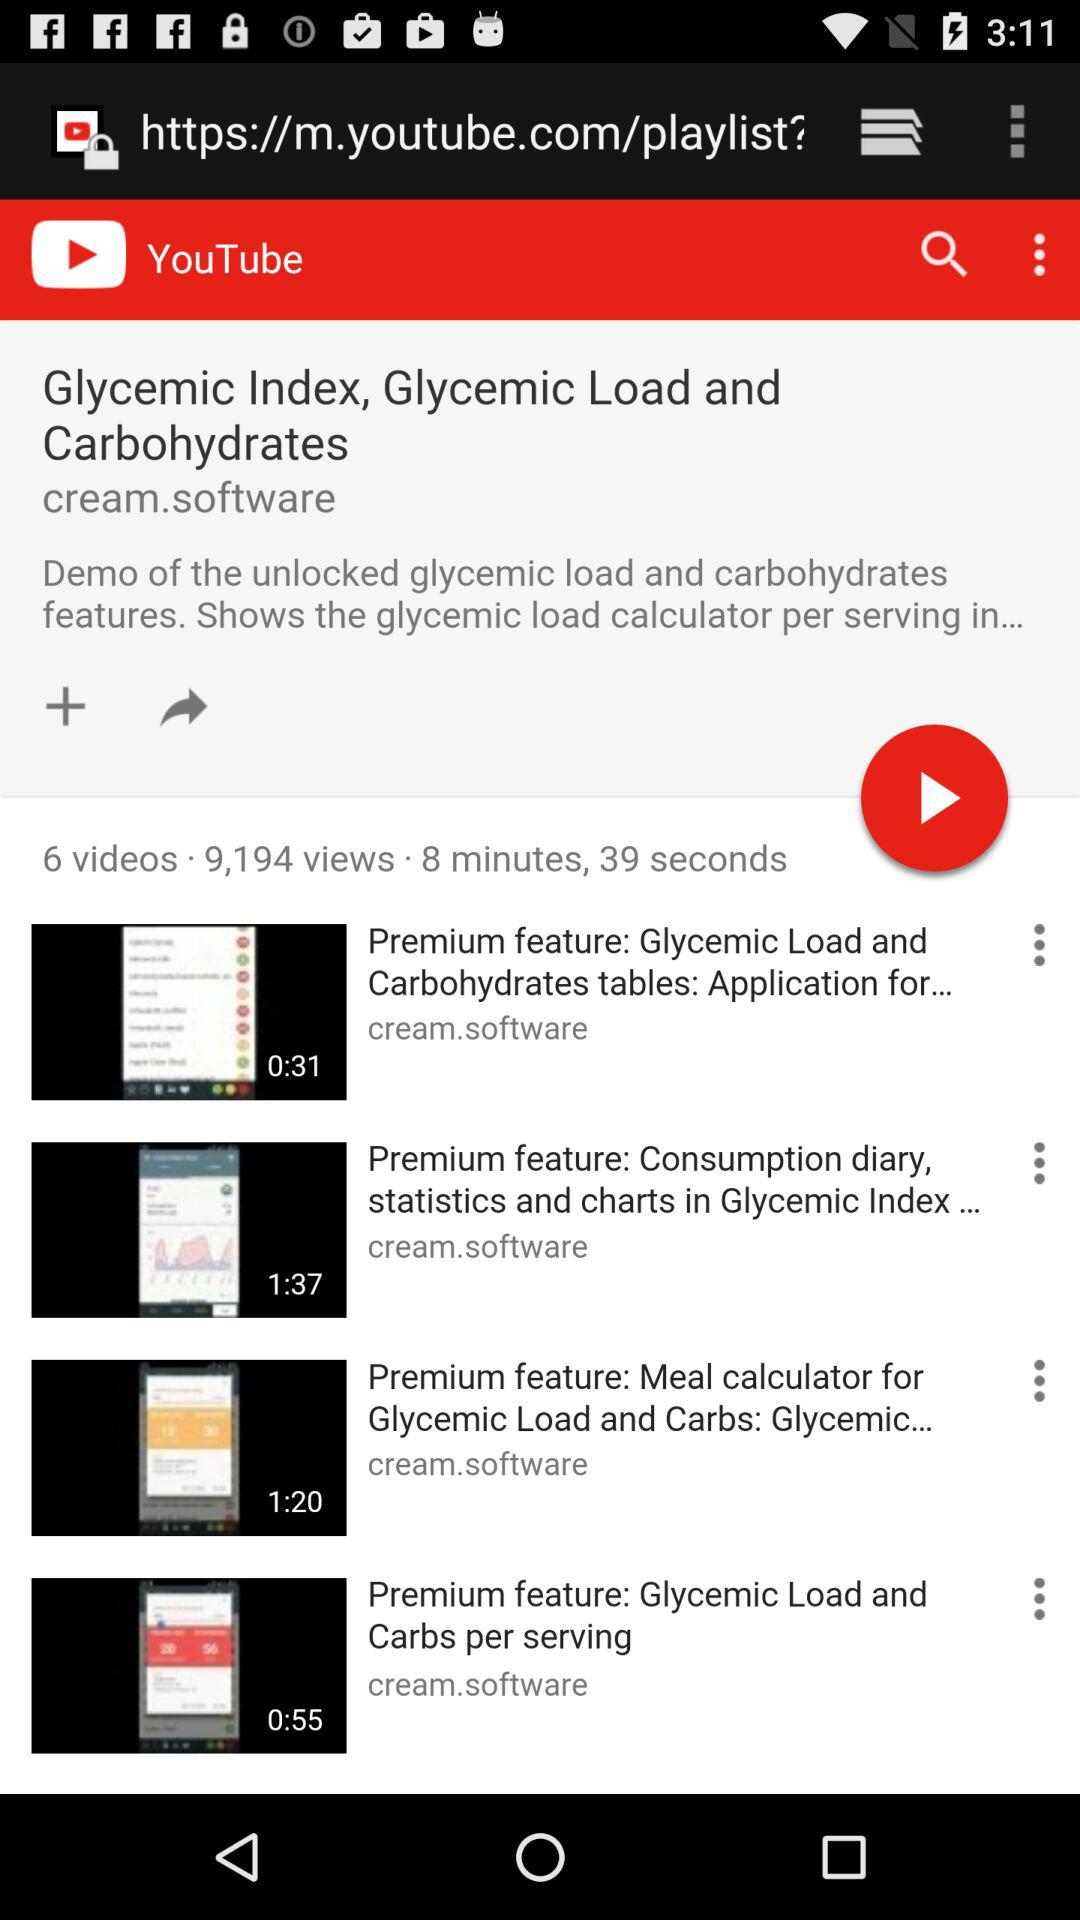How many videos are there? There are 6 videos. 